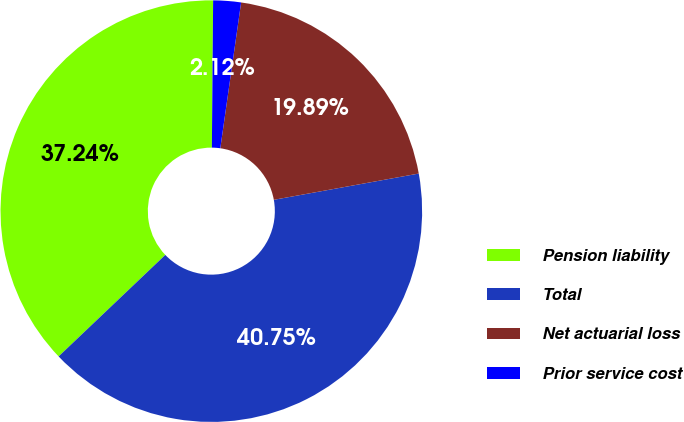Convert chart. <chart><loc_0><loc_0><loc_500><loc_500><pie_chart><fcel>Pension liability<fcel>Total<fcel>Net actuarial loss<fcel>Prior service cost<nl><fcel>37.24%<fcel>40.75%<fcel>19.89%<fcel>2.12%<nl></chart> 